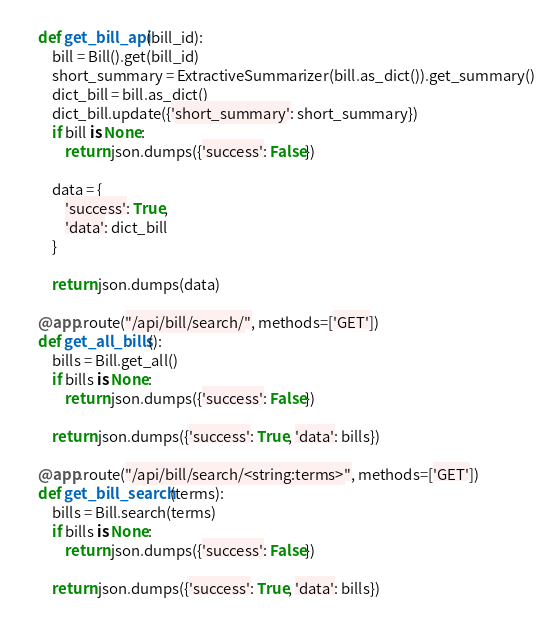<code> <loc_0><loc_0><loc_500><loc_500><_Python_>    def get_bill_api(bill_id):
        bill = Bill().get(bill_id)
        short_summary = ExtractiveSummarizer(bill.as_dict()).get_summary()
        dict_bill = bill.as_dict()
        dict_bill.update({'short_summary': short_summary})
        if bill is None:
            return json.dumps({'success': False})

        data = {
            'success': True,
            'data': dict_bill
        }

        return json.dumps(data)

    @app.route("/api/bill/search/", methods=['GET'])
    def get_all_bills():
        bills = Bill.get_all()
        if bills is None:
            return json.dumps({'success': False})

        return json.dumps({'success': True, 'data': bills})

    @app.route("/api/bill/search/<string:terms>", methods=['GET'])
    def get_bill_search(terms):
        bills = Bill.search(terms)
        if bills is None:
            return json.dumps({'success': False})

        return json.dumps({'success': True, 'data': bills})
</code> 